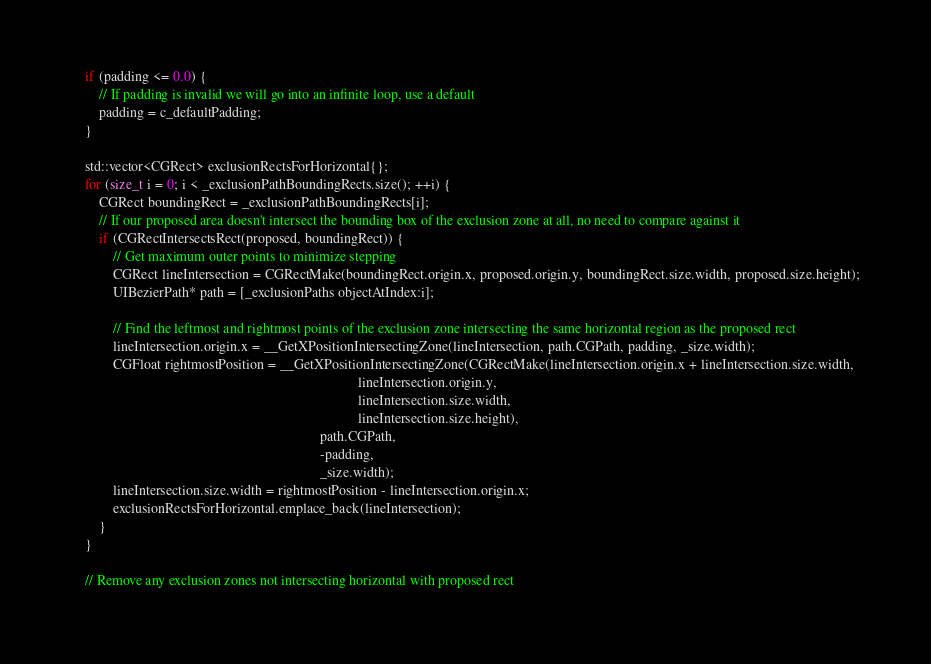<code> <loc_0><loc_0><loc_500><loc_500><_ObjectiveC_>    if (padding <= 0.0) {
        // If padding is invalid we will go into an infinite loop, use a default
        padding = c_defaultPadding;
    }

    std::vector<CGRect> exclusionRectsForHorizontal{};
    for (size_t i = 0; i < _exclusionPathBoundingRects.size(); ++i) {
        CGRect boundingRect = _exclusionPathBoundingRects[i];
        // If our proposed area doesn't intersect the bounding box of the exclusion zone at all, no need to compare against it
        if (CGRectIntersectsRect(proposed, boundingRect)) {
            // Get maximum outer points to minimize stepping
            CGRect lineIntersection = CGRectMake(boundingRect.origin.x, proposed.origin.y, boundingRect.size.width, proposed.size.height);
            UIBezierPath* path = [_exclusionPaths objectAtIndex:i];

            // Find the leftmost and rightmost points of the exclusion zone intersecting the same horizontal region as the proposed rect
            lineIntersection.origin.x = __GetXPositionIntersectingZone(lineIntersection, path.CGPath, padding, _size.width);
            CGFloat rightmostPosition = __GetXPositionIntersectingZone(CGRectMake(lineIntersection.origin.x + lineIntersection.size.width,
                                                                                  lineIntersection.origin.y,
                                                                                  lineIntersection.size.width,
                                                                                  lineIntersection.size.height),
                                                                       path.CGPath,
                                                                       -padding,
                                                                       _size.width);
            lineIntersection.size.width = rightmostPosition - lineIntersection.origin.x;
            exclusionRectsForHorizontal.emplace_back(lineIntersection);
        }
    }

    // Remove any exclusion zones not intersecting horizontal with proposed rect</code> 